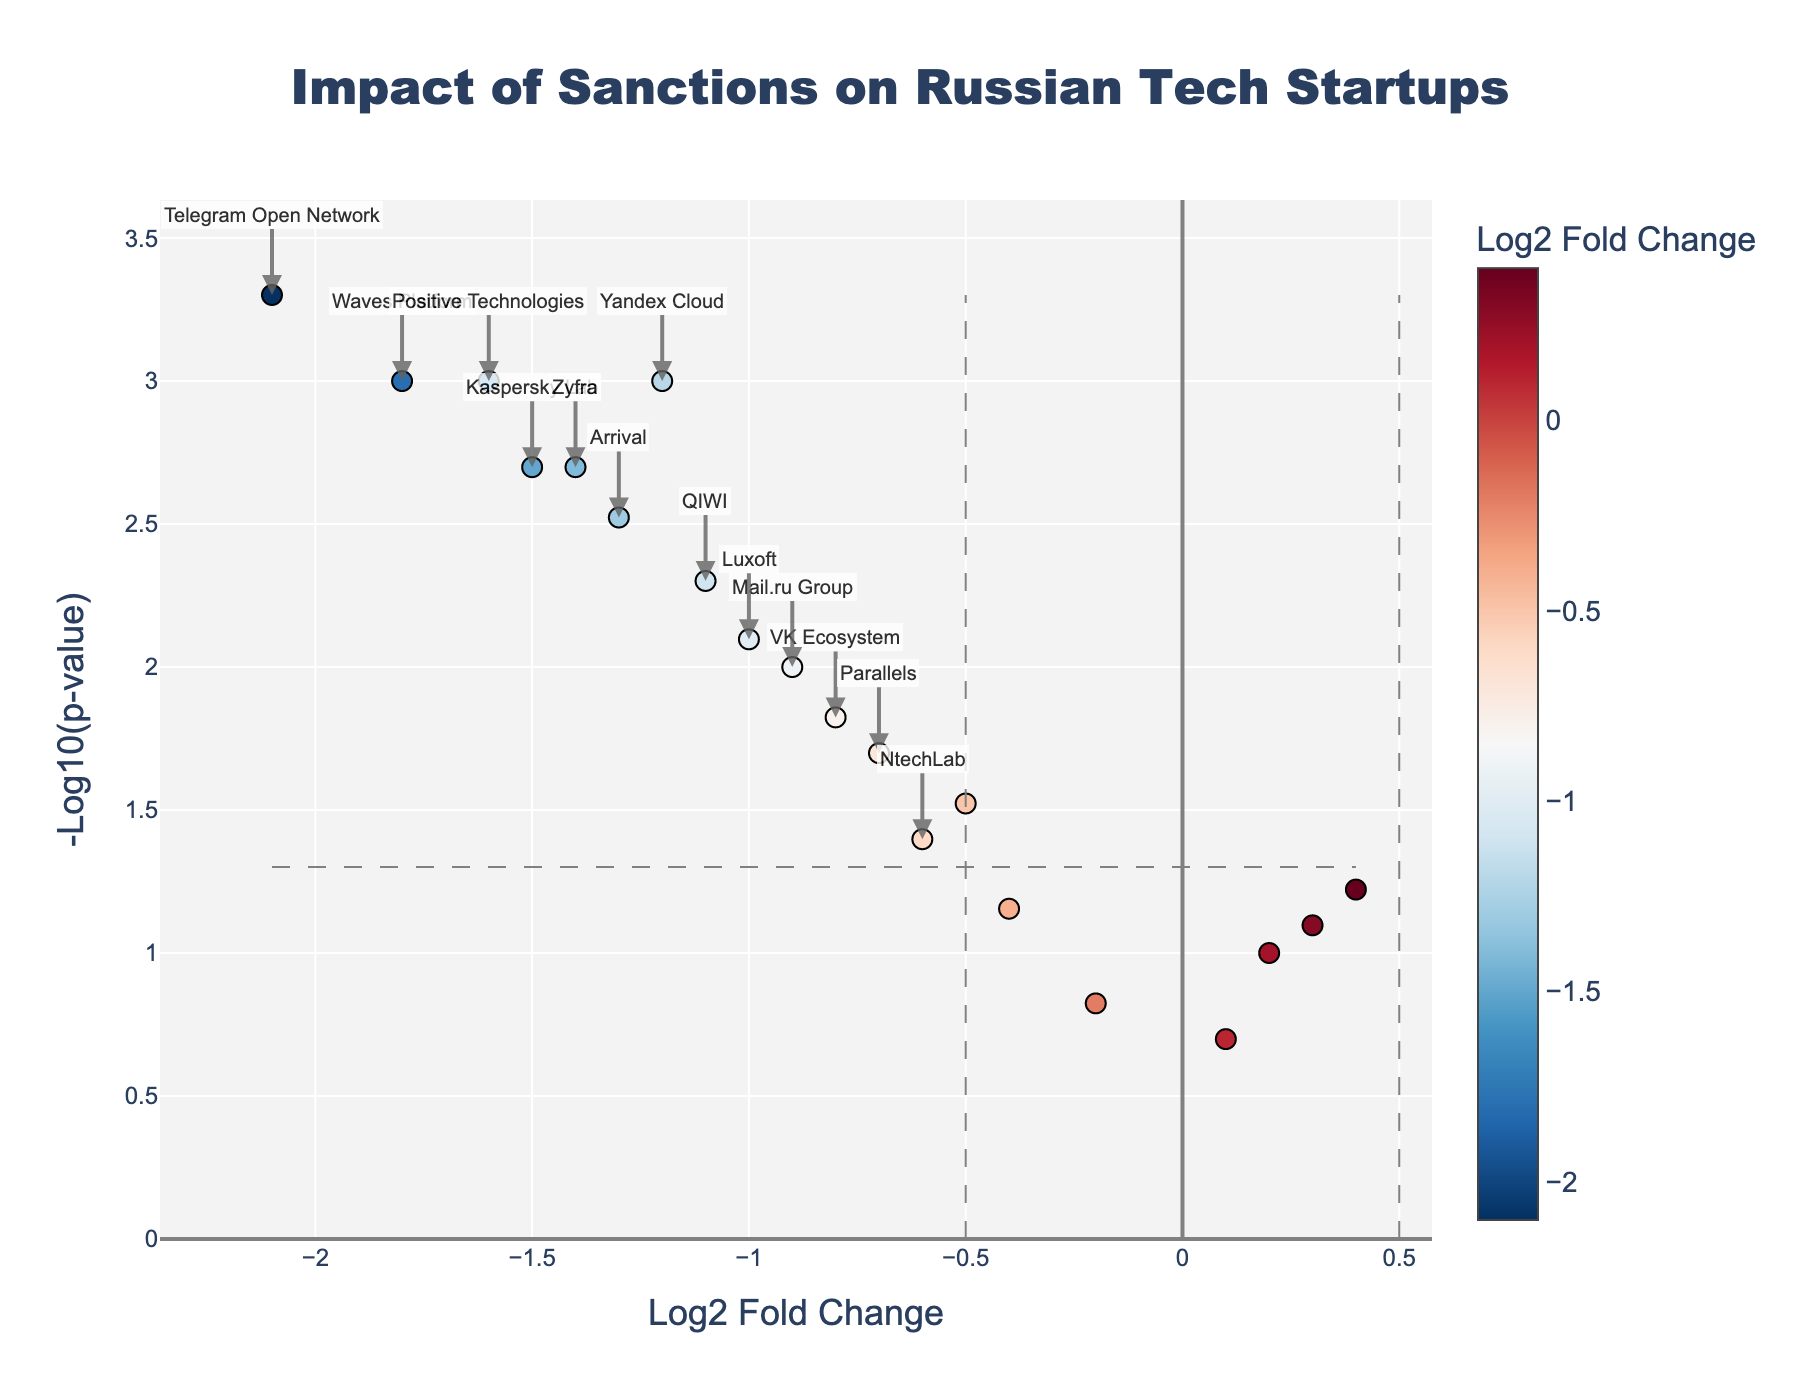Which startup has the highest -log10(p-value)? Locate the point that has the highest y-axis value, representing the highest -log10(p-value). In this case, it is for Telegram Open Network.
Answer: Telegram Open Network What are the log2 fold change and p-value for Veeam Software? Find the point labeled as Veeam Software in the plot and read its coordinates on the x-axis and the y-axis, which correspond to the log2 fold change and -log10(p-value). Veeam Software has a log2 fold change of 0.4 and a p-value that translates to a -log10(p-value) that can be approximately traced back to a p-value of around 0.06.
Answer: 0.4 and 0.06 Which startups show a positive log2 fold change? Identify all the points with a log2 fold change greater than 0, indicating they are on the right side of the vertical zero line. These are Sber AI, Nginx, Veeam Software, and Ecwid.
Answer: Sber AI, Nginx, Veeam Software, Ecwid How many startups have a log2 fold change less than -1 and a p-value less than 0.05? Count the points to the left of -1 (log2 fold change axis) that are also above the -log10(0.05) threshold line. These points represent Yandex Cloud, Telegram Open Network, Kaspersky Lab, Waves Platform, Arrival, Positive Technologies, and Zyfra. In total, there are 7 startups.
Answer: 7 What is the general trend of the startups' log2 fold changes in relation to the sanctions? Observe the distribution of points horizontally. Most startups have negative log2 fold changes, indicating a general decline in funding and growth rates due to sanctions.
Answer: Negative Which startup shows the most impact in terms of funding and growth decline? Locate the point with the most negative log2 fold change and a significant p-value. Telegram Open Network shows the highest impact with the most negative log2 fold change (-2.1) and a highly significant p-value.
Answer: Telegram Open Network Are there any startups with both log2 fold change < -1 and log2 fold change > 1? Scan the plot for any points that lie far left of -1 and far right of 1 on the log2 fold change axis. There are no visible points greater than 1, but several are less than -1, meaning no startups show significant increase while several show a significant decrease.
Answer: No What does a dot's color indicate in the plot? Interpret the color bar on the right side of the plot. Dots are colored based on their log2 fold change values, with a gradient from red to blue where red indicates negative changes and blue positive changes.
Answer: Log2 fold change Which startup has the lowest yet significant p-value? Locate the point closest to the top of the plot, as it represents the lowest p-value. It is Telegram Open Network which also has a significant negative log2 fold change.
Answer: Telegram Open Network 